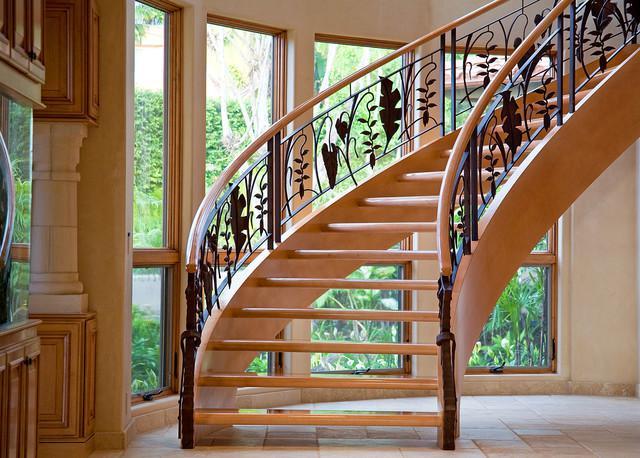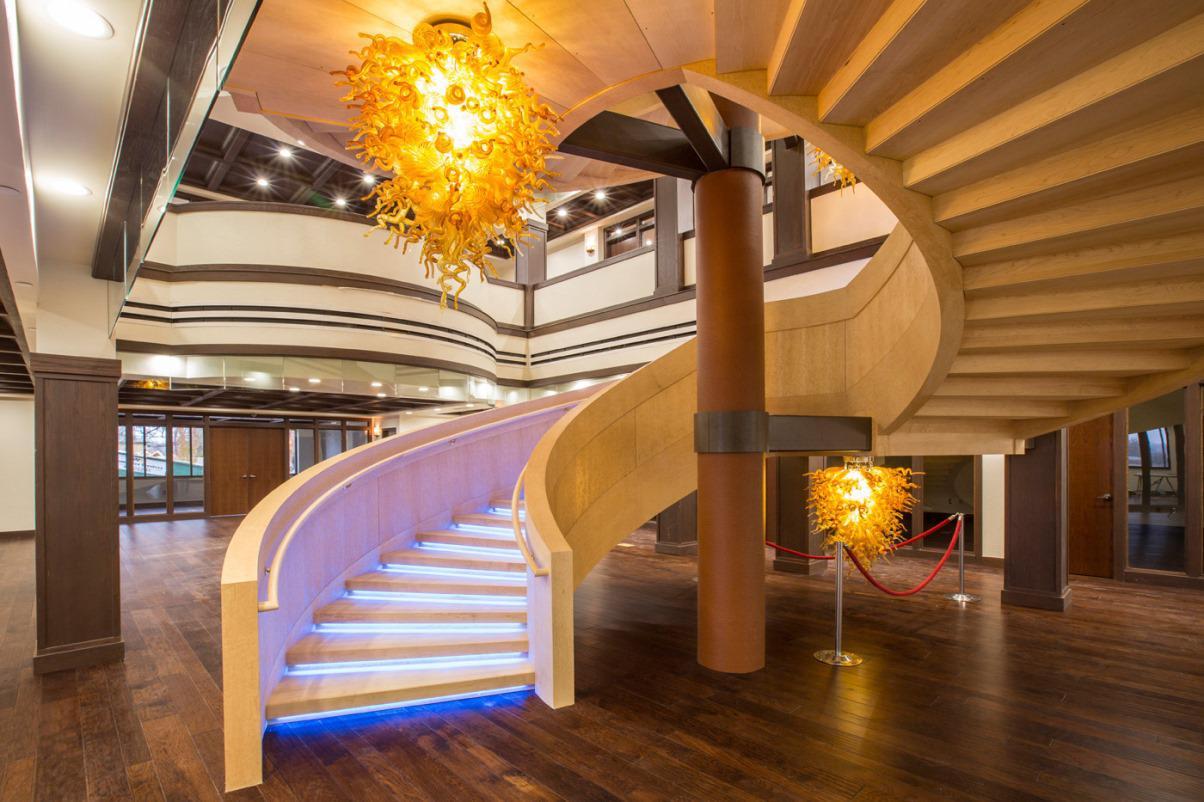The first image is the image on the left, the second image is the image on the right. Considering the images on both sides, is "One of the images shows an entrance to a home and the other image shows a wooden staircase with metal balusters." valid? Answer yes or no. No. The first image is the image on the left, the second image is the image on the right. Examine the images to the left and right. Is the description "The exterior of a house is shown with stairs that have very dark-colored railings." accurate? Answer yes or no. No. 